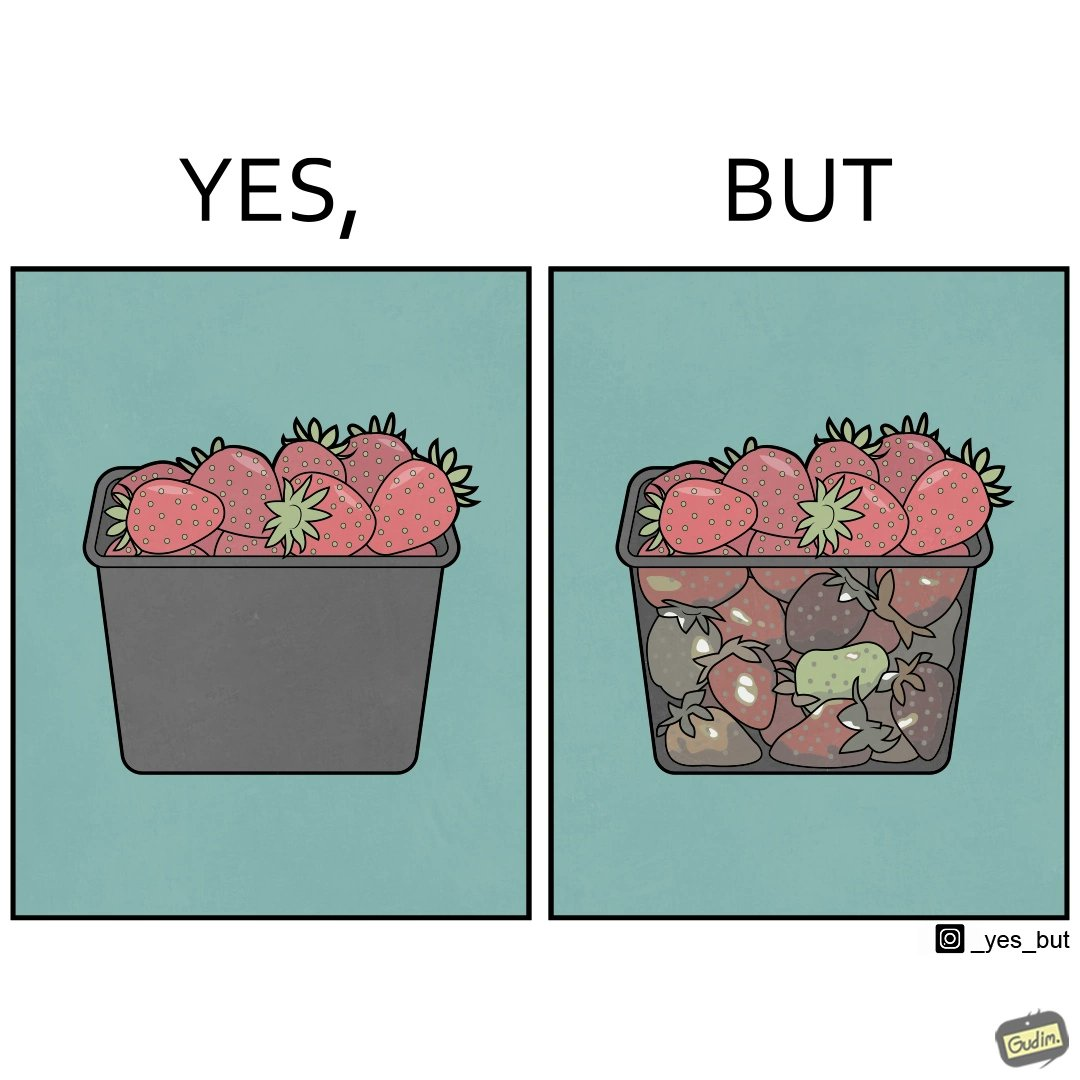Is this a satirical image? Yes, this image is satirical. 